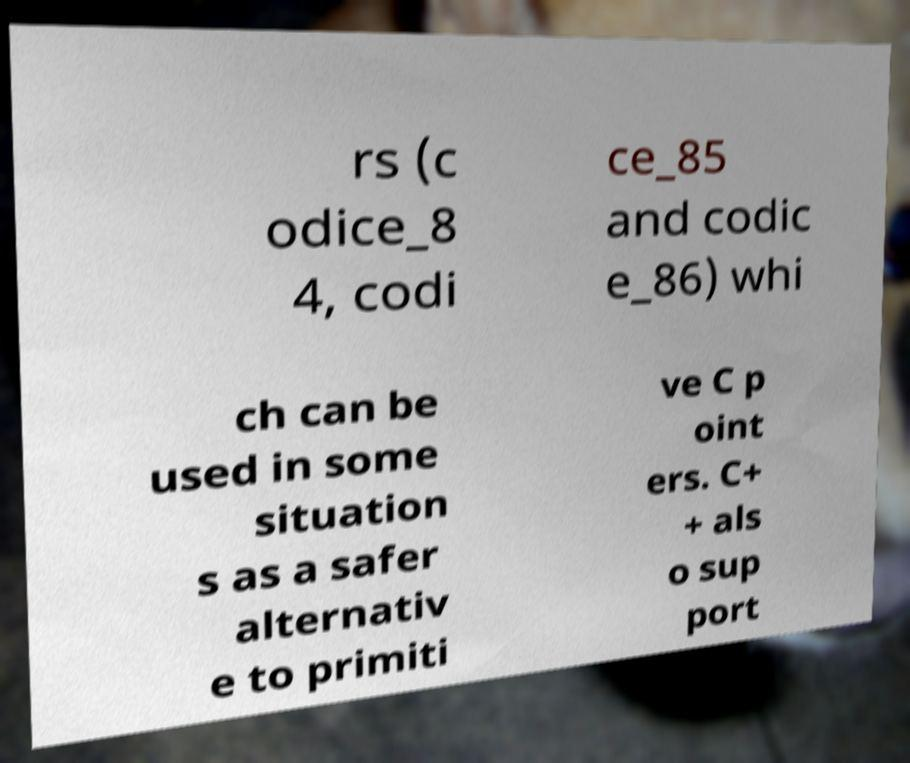Could you assist in decoding the text presented in this image and type it out clearly? rs (c odice_8 4, codi ce_85 and codic e_86) whi ch can be used in some situation s as a safer alternativ e to primiti ve C p oint ers. C+ + als o sup port 